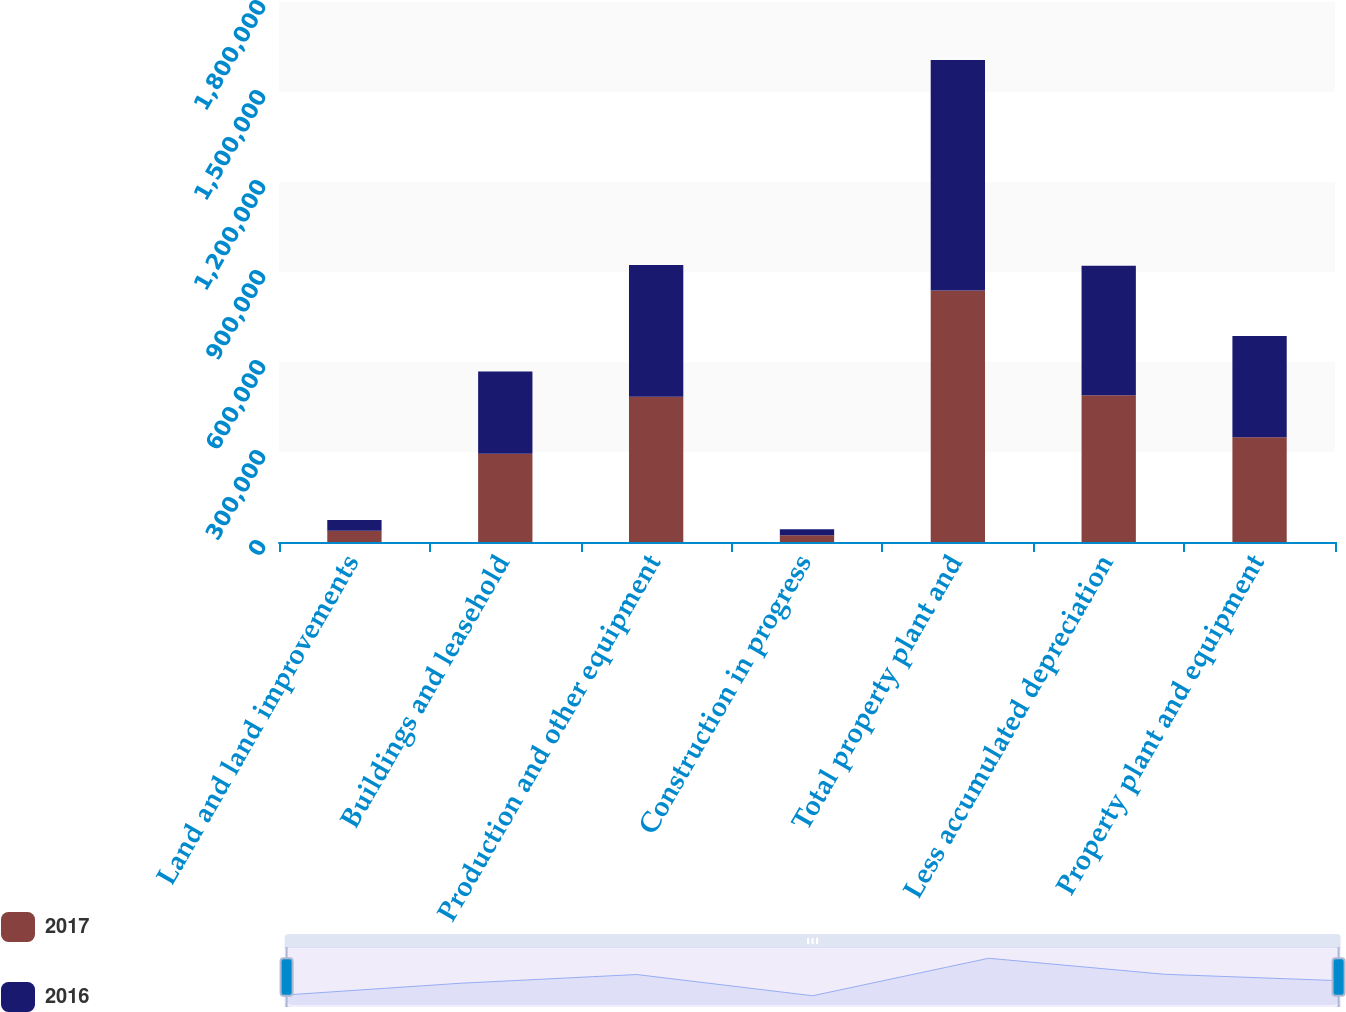Convert chart to OTSL. <chart><loc_0><loc_0><loc_500><loc_500><stacked_bar_chart><ecel><fcel>Land and land improvements<fcel>Buildings and leasehold<fcel>Production and other equipment<fcel>Construction in progress<fcel>Total property plant and<fcel>Less accumulated depreciation<fcel>Property plant and equipment<nl><fcel>2017<fcel>37525<fcel>294219<fcel>484475<fcel>22140<fcel>838359<fcel>489081<fcel>349278<nl><fcel>2016<fcel>35720<fcel>274021<fcel>438604<fcel>20204<fcel>768549<fcel>431431<fcel>337118<nl></chart> 